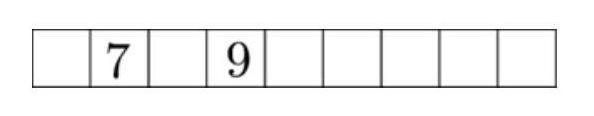Can you explain why some combinations of numbers wouldn't work in this puzzle? Certainly! A combination of numbers won't work if the sum of any three adjacent numbers doesn't meet the criterion of being a multiple of 3. For instance, placing a 1 and 2 next to 7 would result in a sum of 10 (7+1+2), which isn't a multiple of 3 and thereby invalidates this placement in the context of this specific puzzle. 